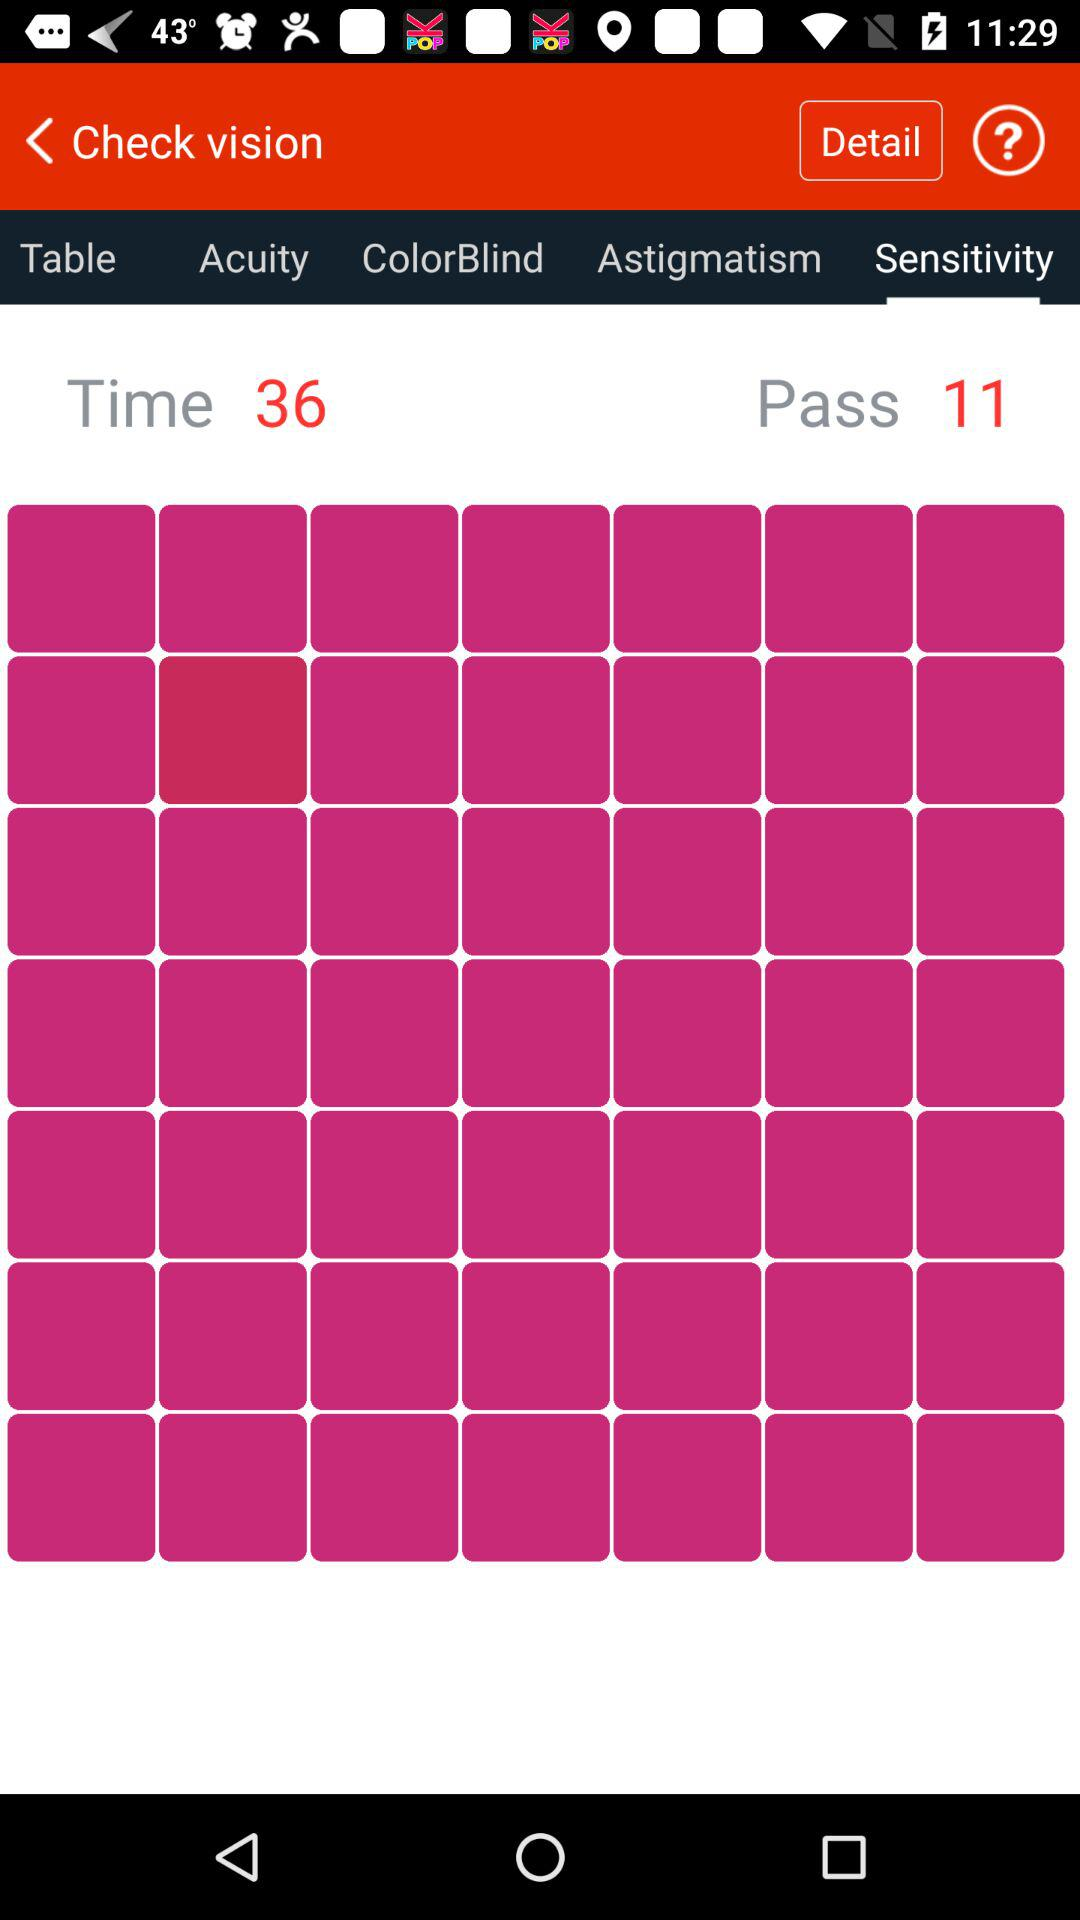What is displayed in time? In time, 36 is displayed. 